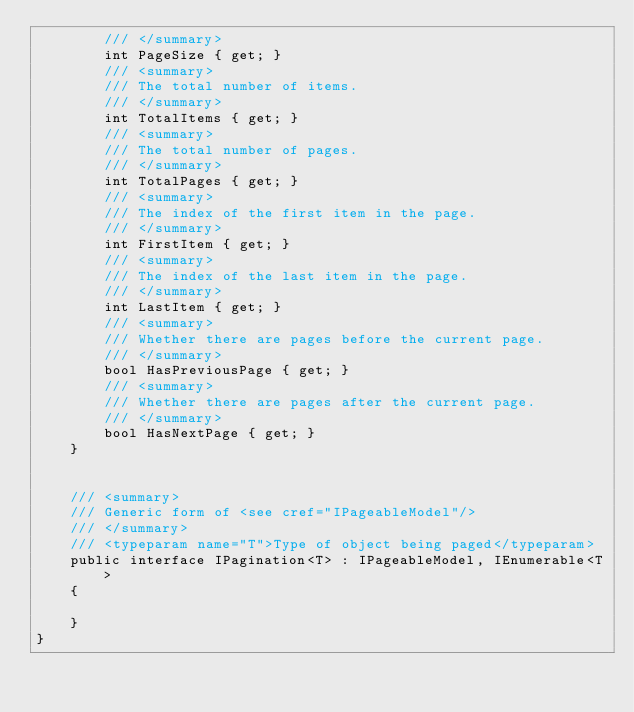Convert code to text. <code><loc_0><loc_0><loc_500><loc_500><_C#_>		/// </summary>
		int PageSize { get; }
		/// <summary>
		/// The total number of items.
		/// </summary>
		int TotalItems { get; }
		/// <summary>
		/// The total number of pages.
		/// </summary>
		int TotalPages { get; }
		/// <summary>
		/// The index of the first item in the page.
		/// </summary>
		int FirstItem { get; }
		/// <summary>
		/// The index of the last item in the page.
		/// </summary>
		int LastItem { get; }
		/// <summary>
		/// Whether there are pages before the current page.
		/// </summary>
		bool HasPreviousPage { get; }
		/// <summary>
		/// Whether there are pages after the current page.
		/// </summary>
		bool HasNextPage { get; }
	}


	/// <summary>
	/// Generic form of <see cref="IPageableModel"/>
	/// </summary>
	/// <typeparam name="T">Type of object being paged</typeparam>
	public interface IPagination<T> : IPageableModel, IEnumerable<T>
	{

	}
}</code> 